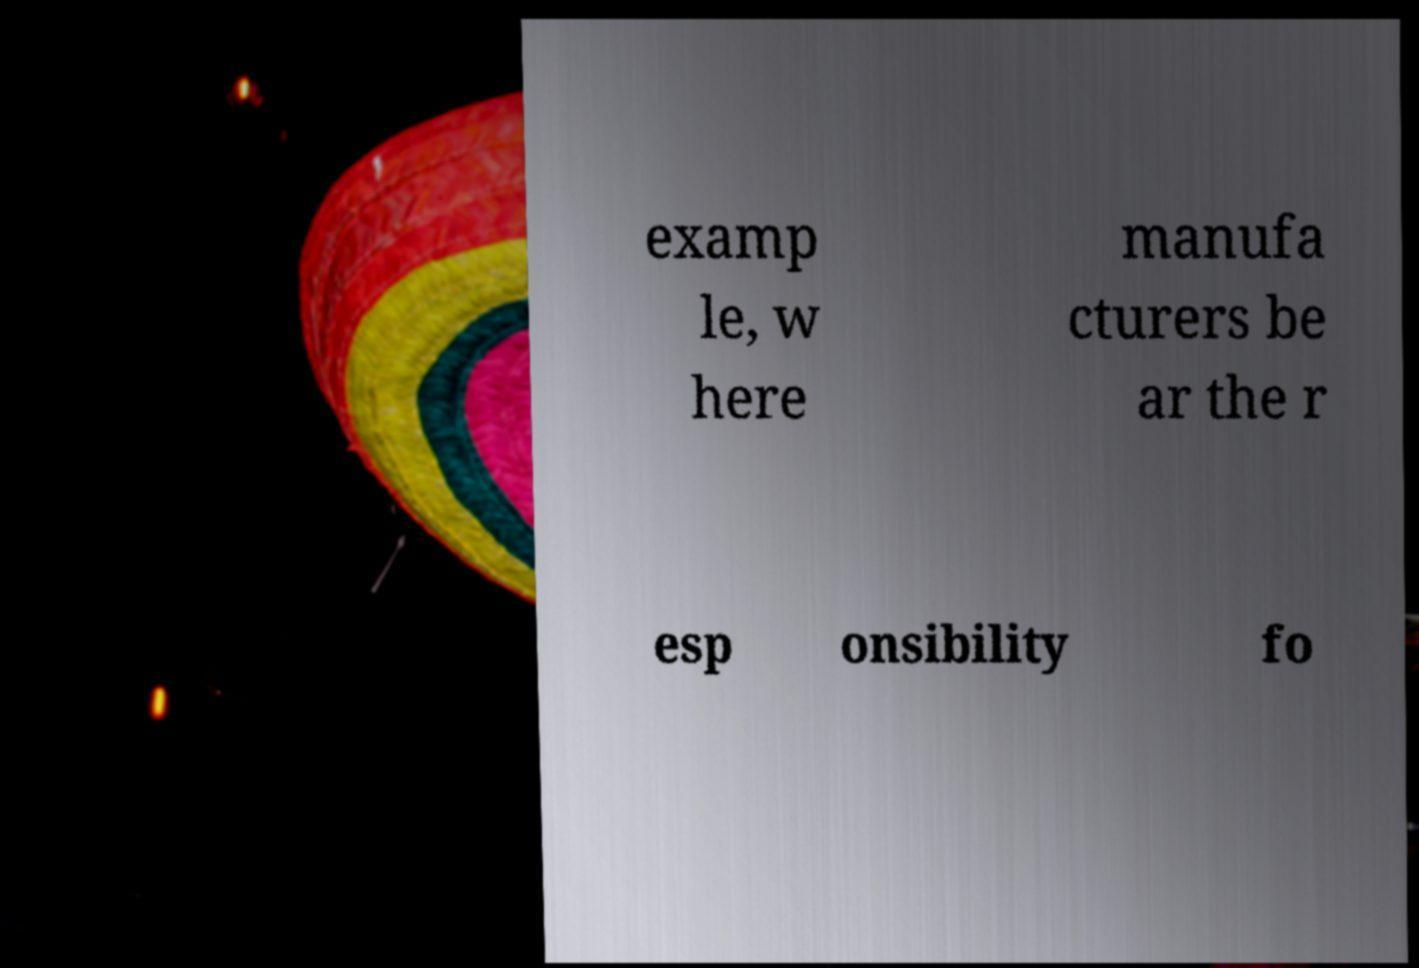Could you assist in decoding the text presented in this image and type it out clearly? examp le, w here manufa cturers be ar the r esp onsibility fo 